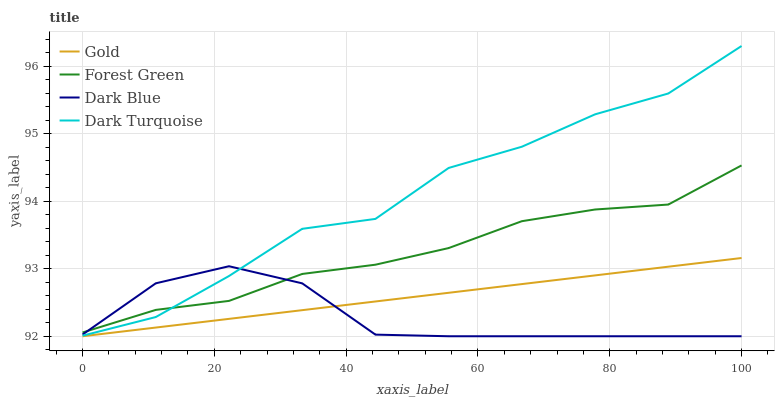Does Dark Blue have the minimum area under the curve?
Answer yes or no. Yes. Does Dark Turquoise have the maximum area under the curve?
Answer yes or no. Yes. Does Forest Green have the minimum area under the curve?
Answer yes or no. No. Does Forest Green have the maximum area under the curve?
Answer yes or no. No. Is Gold the smoothest?
Answer yes or no. Yes. Is Dark Turquoise the roughest?
Answer yes or no. Yes. Is Forest Green the smoothest?
Answer yes or no. No. Is Forest Green the roughest?
Answer yes or no. No. Does Forest Green have the lowest value?
Answer yes or no. No. Does Dark Turquoise have the highest value?
Answer yes or no. Yes. Does Forest Green have the highest value?
Answer yes or no. No. Is Gold less than Forest Green?
Answer yes or no. Yes. Is Forest Green greater than Gold?
Answer yes or no. Yes. Does Dark Turquoise intersect Dark Blue?
Answer yes or no. Yes. Is Dark Turquoise less than Dark Blue?
Answer yes or no. No. Is Dark Turquoise greater than Dark Blue?
Answer yes or no. No. Does Gold intersect Forest Green?
Answer yes or no. No. 